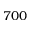<formula> <loc_0><loc_0><loc_500><loc_500>7 0 0</formula> 